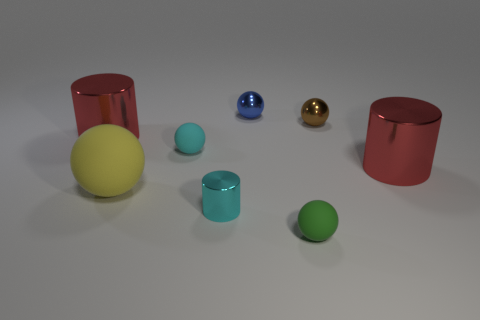Subtract all tiny brown spheres. How many spheres are left? 4 Subtract 1 spheres. How many spheres are left? 4 Subtract all blue balls. How many balls are left? 4 Subtract all gray spheres. Subtract all purple cubes. How many spheres are left? 5 Add 1 brown metal objects. How many objects exist? 9 Subtract all cylinders. How many objects are left? 5 Subtract all cylinders. Subtract all green spheres. How many objects are left? 4 Add 1 green rubber objects. How many green rubber objects are left? 2 Add 4 large spheres. How many large spheres exist? 5 Subtract 0 purple cylinders. How many objects are left? 8 